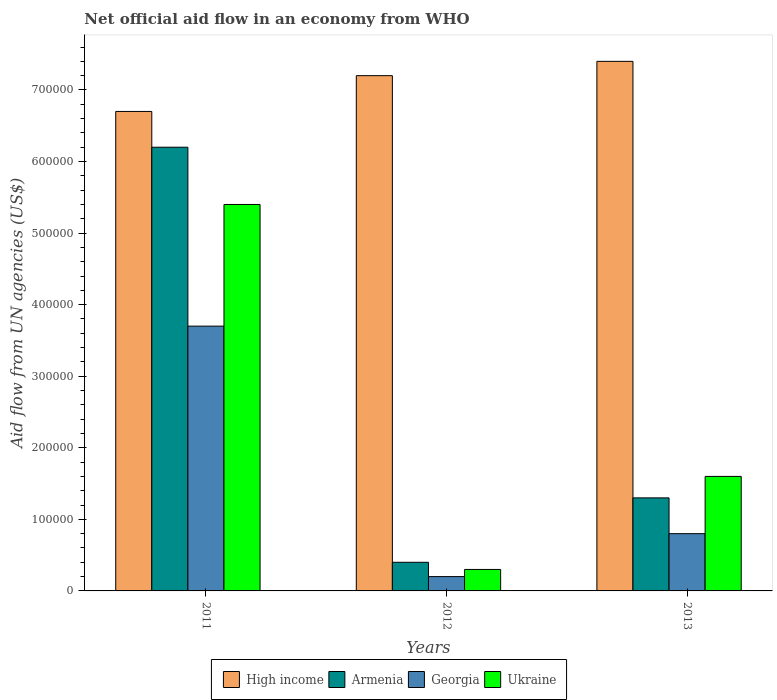How many bars are there on the 2nd tick from the left?
Ensure brevity in your answer.  4. What is the label of the 2nd group of bars from the left?
Provide a short and direct response. 2012. What is the net official aid flow in Armenia in 2011?
Ensure brevity in your answer.  6.20e+05. Across all years, what is the maximum net official aid flow in Ukraine?
Ensure brevity in your answer.  5.40e+05. In which year was the net official aid flow in Ukraine maximum?
Your answer should be very brief. 2011. What is the total net official aid flow in Armenia in the graph?
Keep it short and to the point. 7.90e+05. What is the difference between the net official aid flow in Ukraine in 2011 and that in 2012?
Your response must be concise. 5.10e+05. What is the difference between the net official aid flow in Ukraine in 2012 and the net official aid flow in Georgia in 2013?
Provide a succinct answer. -5.00e+04. What is the average net official aid flow in Georgia per year?
Keep it short and to the point. 1.57e+05. In the year 2013, what is the difference between the net official aid flow in Armenia and net official aid flow in Georgia?
Provide a short and direct response. 5.00e+04. What is the ratio of the net official aid flow in High income in 2012 to that in 2013?
Your answer should be compact. 0.97. Is the net official aid flow in Georgia in 2011 less than that in 2013?
Your answer should be very brief. No. Is the difference between the net official aid flow in Armenia in 2012 and 2013 greater than the difference between the net official aid flow in Georgia in 2012 and 2013?
Provide a short and direct response. No. What is the difference between the highest and the lowest net official aid flow in Armenia?
Keep it short and to the point. 5.80e+05. In how many years, is the net official aid flow in Ukraine greater than the average net official aid flow in Ukraine taken over all years?
Keep it short and to the point. 1. Is the sum of the net official aid flow in High income in 2011 and 2012 greater than the maximum net official aid flow in Ukraine across all years?
Offer a very short reply. Yes. Is it the case that in every year, the sum of the net official aid flow in Ukraine and net official aid flow in High income is greater than the sum of net official aid flow in Georgia and net official aid flow in Armenia?
Keep it short and to the point. Yes. What does the 4th bar from the left in 2011 represents?
Ensure brevity in your answer.  Ukraine. What does the 4th bar from the right in 2011 represents?
Provide a succinct answer. High income. Is it the case that in every year, the sum of the net official aid flow in Georgia and net official aid flow in High income is greater than the net official aid flow in Ukraine?
Offer a terse response. Yes. Are all the bars in the graph horizontal?
Provide a short and direct response. No. What is the difference between two consecutive major ticks on the Y-axis?
Ensure brevity in your answer.  1.00e+05. Are the values on the major ticks of Y-axis written in scientific E-notation?
Your response must be concise. No. Does the graph contain grids?
Your answer should be very brief. No. How many legend labels are there?
Ensure brevity in your answer.  4. What is the title of the graph?
Provide a short and direct response. Net official aid flow in an economy from WHO. Does "Korea (Republic)" appear as one of the legend labels in the graph?
Your response must be concise. No. What is the label or title of the X-axis?
Offer a very short reply. Years. What is the label or title of the Y-axis?
Keep it short and to the point. Aid flow from UN agencies (US$). What is the Aid flow from UN agencies (US$) in High income in 2011?
Offer a very short reply. 6.70e+05. What is the Aid flow from UN agencies (US$) of Armenia in 2011?
Offer a very short reply. 6.20e+05. What is the Aid flow from UN agencies (US$) in Georgia in 2011?
Your answer should be compact. 3.70e+05. What is the Aid flow from UN agencies (US$) in Ukraine in 2011?
Provide a succinct answer. 5.40e+05. What is the Aid flow from UN agencies (US$) of High income in 2012?
Provide a succinct answer. 7.20e+05. What is the Aid flow from UN agencies (US$) in Armenia in 2012?
Provide a succinct answer. 4.00e+04. What is the Aid flow from UN agencies (US$) of Ukraine in 2012?
Give a very brief answer. 3.00e+04. What is the Aid flow from UN agencies (US$) in High income in 2013?
Your answer should be very brief. 7.40e+05. What is the Aid flow from UN agencies (US$) of Armenia in 2013?
Your answer should be compact. 1.30e+05. What is the Aid flow from UN agencies (US$) in Georgia in 2013?
Give a very brief answer. 8.00e+04. Across all years, what is the maximum Aid flow from UN agencies (US$) of High income?
Provide a succinct answer. 7.40e+05. Across all years, what is the maximum Aid flow from UN agencies (US$) in Armenia?
Your answer should be very brief. 6.20e+05. Across all years, what is the maximum Aid flow from UN agencies (US$) in Georgia?
Provide a short and direct response. 3.70e+05. Across all years, what is the maximum Aid flow from UN agencies (US$) of Ukraine?
Provide a succinct answer. 5.40e+05. Across all years, what is the minimum Aid flow from UN agencies (US$) of High income?
Provide a short and direct response. 6.70e+05. What is the total Aid flow from UN agencies (US$) of High income in the graph?
Your answer should be compact. 2.13e+06. What is the total Aid flow from UN agencies (US$) in Armenia in the graph?
Offer a very short reply. 7.90e+05. What is the total Aid flow from UN agencies (US$) of Georgia in the graph?
Give a very brief answer. 4.70e+05. What is the total Aid flow from UN agencies (US$) of Ukraine in the graph?
Provide a short and direct response. 7.30e+05. What is the difference between the Aid flow from UN agencies (US$) in High income in 2011 and that in 2012?
Your response must be concise. -5.00e+04. What is the difference between the Aid flow from UN agencies (US$) of Armenia in 2011 and that in 2012?
Offer a very short reply. 5.80e+05. What is the difference between the Aid flow from UN agencies (US$) in Georgia in 2011 and that in 2012?
Offer a terse response. 3.50e+05. What is the difference between the Aid flow from UN agencies (US$) in Ukraine in 2011 and that in 2012?
Provide a short and direct response. 5.10e+05. What is the difference between the Aid flow from UN agencies (US$) in Armenia in 2011 and that in 2013?
Offer a very short reply. 4.90e+05. What is the difference between the Aid flow from UN agencies (US$) in High income in 2012 and that in 2013?
Offer a terse response. -2.00e+04. What is the difference between the Aid flow from UN agencies (US$) of Armenia in 2012 and that in 2013?
Provide a succinct answer. -9.00e+04. What is the difference between the Aid flow from UN agencies (US$) of Georgia in 2012 and that in 2013?
Make the answer very short. -6.00e+04. What is the difference between the Aid flow from UN agencies (US$) of Ukraine in 2012 and that in 2013?
Give a very brief answer. -1.30e+05. What is the difference between the Aid flow from UN agencies (US$) of High income in 2011 and the Aid flow from UN agencies (US$) of Armenia in 2012?
Your answer should be compact. 6.30e+05. What is the difference between the Aid flow from UN agencies (US$) in High income in 2011 and the Aid flow from UN agencies (US$) in Georgia in 2012?
Make the answer very short. 6.50e+05. What is the difference between the Aid flow from UN agencies (US$) of High income in 2011 and the Aid flow from UN agencies (US$) of Ukraine in 2012?
Provide a short and direct response. 6.40e+05. What is the difference between the Aid flow from UN agencies (US$) in Armenia in 2011 and the Aid flow from UN agencies (US$) in Georgia in 2012?
Keep it short and to the point. 6.00e+05. What is the difference between the Aid flow from UN agencies (US$) in Armenia in 2011 and the Aid flow from UN agencies (US$) in Ukraine in 2012?
Offer a very short reply. 5.90e+05. What is the difference between the Aid flow from UN agencies (US$) of Georgia in 2011 and the Aid flow from UN agencies (US$) of Ukraine in 2012?
Offer a very short reply. 3.40e+05. What is the difference between the Aid flow from UN agencies (US$) in High income in 2011 and the Aid flow from UN agencies (US$) in Armenia in 2013?
Give a very brief answer. 5.40e+05. What is the difference between the Aid flow from UN agencies (US$) in High income in 2011 and the Aid flow from UN agencies (US$) in Georgia in 2013?
Offer a very short reply. 5.90e+05. What is the difference between the Aid flow from UN agencies (US$) in High income in 2011 and the Aid flow from UN agencies (US$) in Ukraine in 2013?
Your answer should be very brief. 5.10e+05. What is the difference between the Aid flow from UN agencies (US$) of Armenia in 2011 and the Aid flow from UN agencies (US$) of Georgia in 2013?
Your answer should be very brief. 5.40e+05. What is the difference between the Aid flow from UN agencies (US$) in Armenia in 2011 and the Aid flow from UN agencies (US$) in Ukraine in 2013?
Offer a very short reply. 4.60e+05. What is the difference between the Aid flow from UN agencies (US$) in High income in 2012 and the Aid flow from UN agencies (US$) in Armenia in 2013?
Offer a very short reply. 5.90e+05. What is the difference between the Aid flow from UN agencies (US$) of High income in 2012 and the Aid flow from UN agencies (US$) of Georgia in 2013?
Make the answer very short. 6.40e+05. What is the difference between the Aid flow from UN agencies (US$) in High income in 2012 and the Aid flow from UN agencies (US$) in Ukraine in 2013?
Ensure brevity in your answer.  5.60e+05. What is the difference between the Aid flow from UN agencies (US$) of Armenia in 2012 and the Aid flow from UN agencies (US$) of Georgia in 2013?
Keep it short and to the point. -4.00e+04. What is the difference between the Aid flow from UN agencies (US$) in Armenia in 2012 and the Aid flow from UN agencies (US$) in Ukraine in 2013?
Provide a succinct answer. -1.20e+05. What is the average Aid flow from UN agencies (US$) in High income per year?
Your response must be concise. 7.10e+05. What is the average Aid flow from UN agencies (US$) in Armenia per year?
Offer a terse response. 2.63e+05. What is the average Aid flow from UN agencies (US$) in Georgia per year?
Your response must be concise. 1.57e+05. What is the average Aid flow from UN agencies (US$) in Ukraine per year?
Your answer should be very brief. 2.43e+05. In the year 2011, what is the difference between the Aid flow from UN agencies (US$) in High income and Aid flow from UN agencies (US$) in Georgia?
Your answer should be very brief. 3.00e+05. In the year 2011, what is the difference between the Aid flow from UN agencies (US$) in High income and Aid flow from UN agencies (US$) in Ukraine?
Give a very brief answer. 1.30e+05. In the year 2011, what is the difference between the Aid flow from UN agencies (US$) in Georgia and Aid flow from UN agencies (US$) in Ukraine?
Your answer should be very brief. -1.70e+05. In the year 2012, what is the difference between the Aid flow from UN agencies (US$) in High income and Aid flow from UN agencies (US$) in Armenia?
Make the answer very short. 6.80e+05. In the year 2012, what is the difference between the Aid flow from UN agencies (US$) of High income and Aid flow from UN agencies (US$) of Ukraine?
Your answer should be compact. 6.90e+05. In the year 2012, what is the difference between the Aid flow from UN agencies (US$) of Armenia and Aid flow from UN agencies (US$) of Ukraine?
Your answer should be compact. 10000. In the year 2012, what is the difference between the Aid flow from UN agencies (US$) in Georgia and Aid flow from UN agencies (US$) in Ukraine?
Ensure brevity in your answer.  -10000. In the year 2013, what is the difference between the Aid flow from UN agencies (US$) of High income and Aid flow from UN agencies (US$) of Armenia?
Ensure brevity in your answer.  6.10e+05. In the year 2013, what is the difference between the Aid flow from UN agencies (US$) of High income and Aid flow from UN agencies (US$) of Georgia?
Offer a terse response. 6.60e+05. In the year 2013, what is the difference between the Aid flow from UN agencies (US$) in High income and Aid flow from UN agencies (US$) in Ukraine?
Your response must be concise. 5.80e+05. In the year 2013, what is the difference between the Aid flow from UN agencies (US$) of Georgia and Aid flow from UN agencies (US$) of Ukraine?
Offer a terse response. -8.00e+04. What is the ratio of the Aid flow from UN agencies (US$) of High income in 2011 to that in 2012?
Provide a succinct answer. 0.93. What is the ratio of the Aid flow from UN agencies (US$) in Armenia in 2011 to that in 2012?
Offer a very short reply. 15.5. What is the ratio of the Aid flow from UN agencies (US$) of Ukraine in 2011 to that in 2012?
Ensure brevity in your answer.  18. What is the ratio of the Aid flow from UN agencies (US$) of High income in 2011 to that in 2013?
Offer a very short reply. 0.91. What is the ratio of the Aid flow from UN agencies (US$) of Armenia in 2011 to that in 2013?
Offer a very short reply. 4.77. What is the ratio of the Aid flow from UN agencies (US$) in Georgia in 2011 to that in 2013?
Offer a terse response. 4.62. What is the ratio of the Aid flow from UN agencies (US$) in Ukraine in 2011 to that in 2013?
Provide a succinct answer. 3.38. What is the ratio of the Aid flow from UN agencies (US$) of High income in 2012 to that in 2013?
Keep it short and to the point. 0.97. What is the ratio of the Aid flow from UN agencies (US$) in Armenia in 2012 to that in 2013?
Your response must be concise. 0.31. What is the ratio of the Aid flow from UN agencies (US$) of Georgia in 2012 to that in 2013?
Provide a succinct answer. 0.25. What is the ratio of the Aid flow from UN agencies (US$) of Ukraine in 2012 to that in 2013?
Ensure brevity in your answer.  0.19. What is the difference between the highest and the second highest Aid flow from UN agencies (US$) in Armenia?
Provide a short and direct response. 4.90e+05. What is the difference between the highest and the second highest Aid flow from UN agencies (US$) of Georgia?
Provide a short and direct response. 2.90e+05. What is the difference between the highest and the second highest Aid flow from UN agencies (US$) of Ukraine?
Your answer should be very brief. 3.80e+05. What is the difference between the highest and the lowest Aid flow from UN agencies (US$) of Armenia?
Your response must be concise. 5.80e+05. What is the difference between the highest and the lowest Aid flow from UN agencies (US$) of Ukraine?
Offer a very short reply. 5.10e+05. 